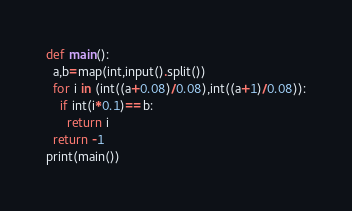Convert code to text. <code><loc_0><loc_0><loc_500><loc_500><_Python_>def main():
  a,b=map(int,input().split())
  for i in (int((a+0.08)/0.08),int((a+1)/0.08)):
    if int(i*0.1)==b:
      return i
  return -1
print(main())</code> 